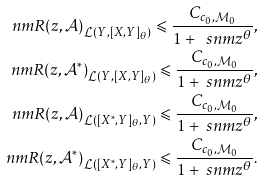Convert formula to latex. <formula><loc_0><loc_0><loc_500><loc_500>\ n m { R ( z , \mathcal { A } ) } _ { \mathcal { L } ( Y , [ X , Y ] _ { \theta } ) } \leqslant \frac { C _ { c _ { 0 } , \mathcal { M } _ { 0 } } } { 1 + \ s n m { z } ^ { \theta } } , \\ \ n m { R ( z , \mathcal { A } ^ { * } ) } _ { \mathcal { L } ( Y , [ X , Y ] _ { \theta } ) } \leqslant \frac { C _ { c _ { 0 } , \mathcal { M } _ { 0 } } } { 1 + \ s n m { z } ^ { \theta } } , \\ \ n m { R ( z , \mathcal { A } ) } _ { \mathcal { L } ( [ X ^ { * } , Y ] _ { \theta } , Y ) } \leqslant \frac { C _ { c _ { 0 } , \mathcal { M } _ { 0 } } } { 1 + \ s n m { z } ^ { \theta } } , \\ \ n m { R ( z , \mathcal { A } ^ { * } ) } _ { \mathcal { L } ( [ X ^ { * } , Y ] _ { \theta } , Y ) } \leqslant \frac { C _ { c _ { 0 } , \mathcal { M } _ { 0 } } } { 1 + \ s n m { z } ^ { \theta } } .</formula> 